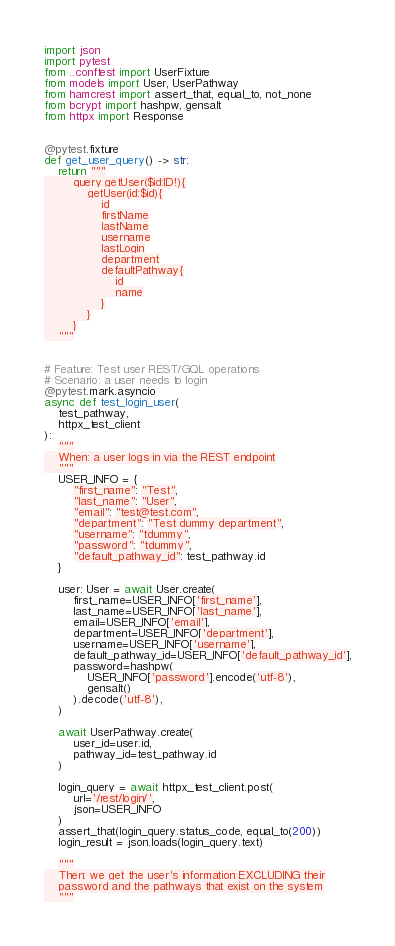Convert code to text. <code><loc_0><loc_0><loc_500><loc_500><_Python_>import json
import pytest
from ..conftest import UserFixture
from models import User, UserPathway
from hamcrest import assert_that, equal_to, not_none
from bcrypt import hashpw, gensalt
from httpx import Response


@pytest.fixture
def get_user_query() -> str:
    return """
        query getUser($id:ID!){
            getUser(id:$id){
                id
                firstName
                lastName
                username
                lastLogin
                department
                defaultPathway{
                    id
                    name
                }
            }
        }
    """


# Feature: Test user REST/GQL operations
# Scenario: a user needs to login
@pytest.mark.asyncio
async def test_login_user(
    test_pathway,
    httpx_test_client
):
    """
    When: a user logs in via the REST endpoint
    """
    USER_INFO = {
        "first_name": "Test",
        "last_name": "User",
        "email": "test@test.com",
        "department": "Test dummy department",
        "username": "tdummy",
        "password": "tdummy",
        "default_pathway_id": test_pathway.id
    }

    user: User = await User.create(
        first_name=USER_INFO['first_name'],
        last_name=USER_INFO['last_name'],
        email=USER_INFO['email'],
        department=USER_INFO['department'],
        username=USER_INFO['username'],
        default_pathway_id=USER_INFO['default_pathway_id'],
        password=hashpw(
            USER_INFO['password'].encode('utf-8'),
            gensalt()
        ).decode('utf-8'),
    )

    await UserPathway.create(
        user_id=user.id,
        pathway_id=test_pathway.id
    )

    login_query = await httpx_test_client.post(
        url='/rest/login/',
        json=USER_INFO
    )
    assert_that(login_query.status_code, equal_to(200))
    login_result = json.loads(login_query.text)

    """
    Then: we get the user's information EXCLUDING their
    password and the pathways that exist on the system
    """
</code> 